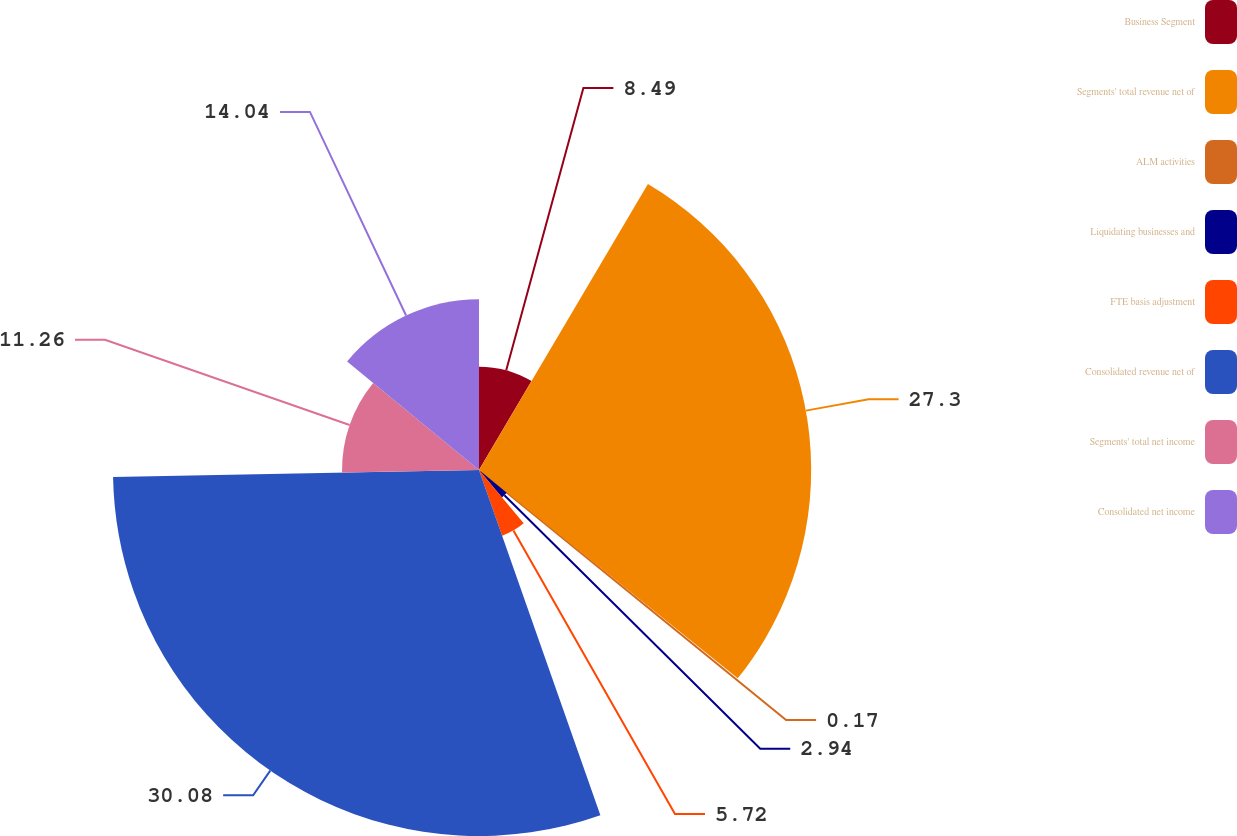Convert chart to OTSL. <chart><loc_0><loc_0><loc_500><loc_500><pie_chart><fcel>Business Segment<fcel>Segments' total revenue net of<fcel>ALM activities<fcel>Liquidating businesses and<fcel>FTE basis adjustment<fcel>Consolidated revenue net of<fcel>Segments' total net income<fcel>Consolidated net income<nl><fcel>8.49%<fcel>27.3%<fcel>0.17%<fcel>2.94%<fcel>5.72%<fcel>30.08%<fcel>11.26%<fcel>14.04%<nl></chart> 